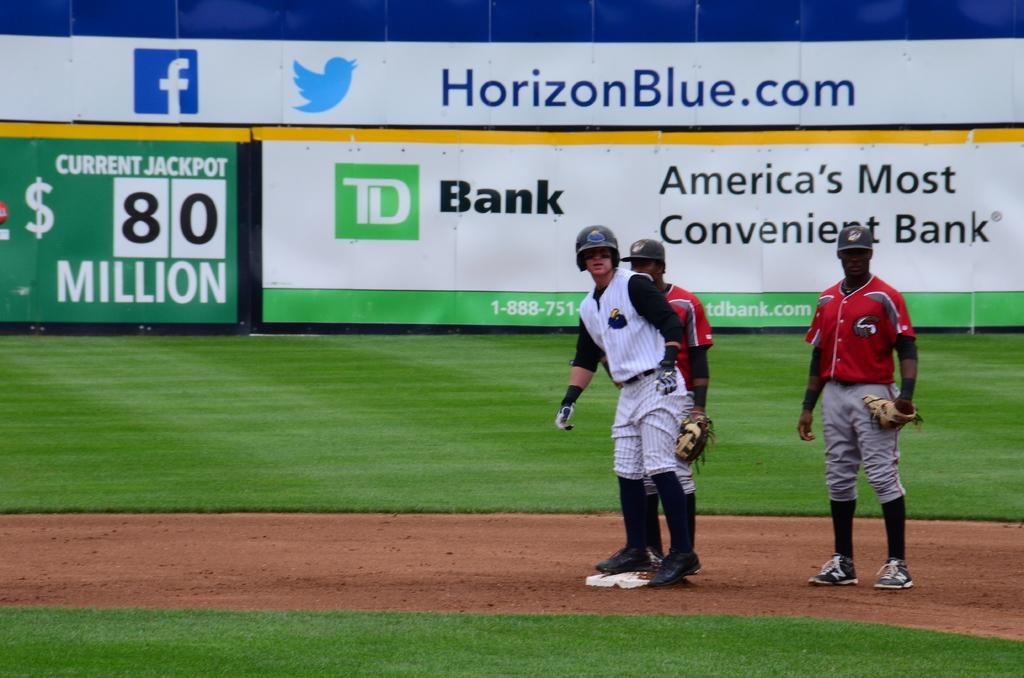<image>
Summarize the visual content of the image. A player is second base with an advertisement from TD Bank in the background. 